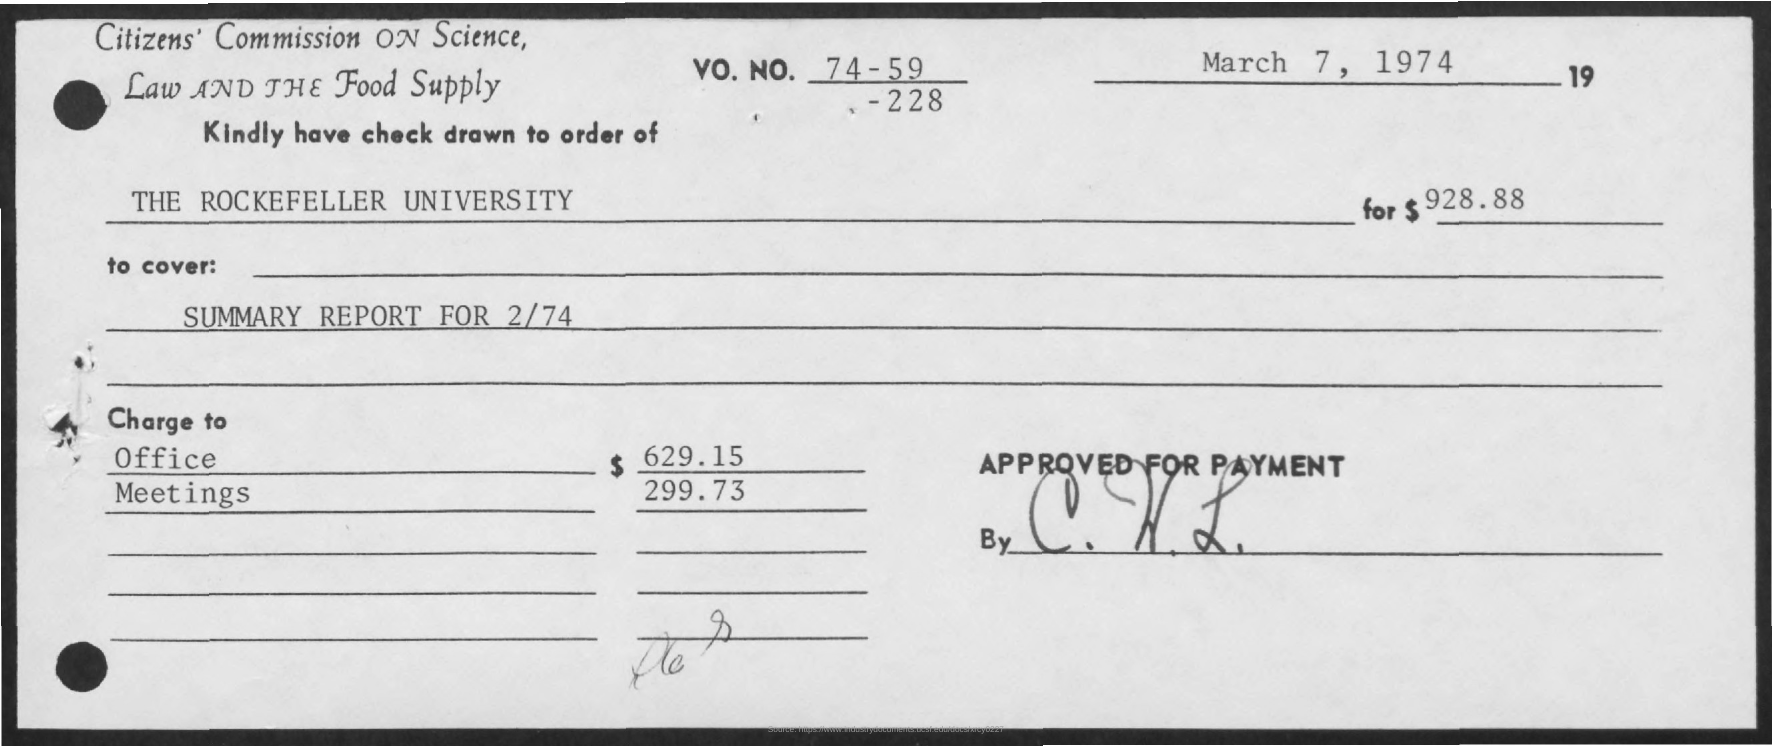Check is drawn to the order of?
Provide a short and direct response. The Rockefeller University. What will it cover?
Offer a terse response. Summary Report for 2/74. What is the "charge to" for Office?
Your answer should be compact. $629.15. What is the VO. NO.?
Keep it short and to the point. 74-59-228. What is the date on the document?
Give a very brief answer. March 7, 1974. 